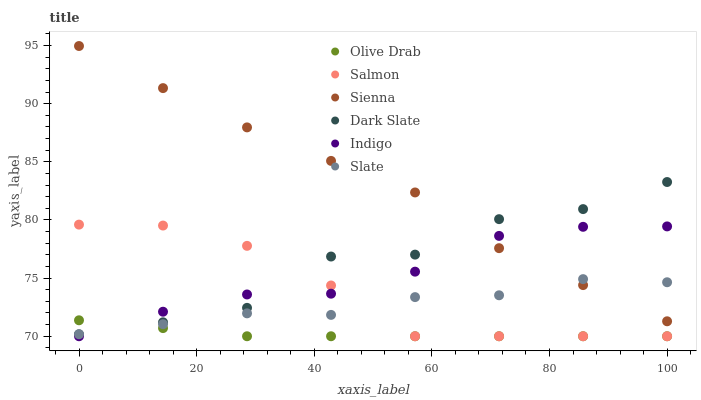Does Olive Drab have the minimum area under the curve?
Answer yes or no. Yes. Does Sienna have the maximum area under the curve?
Answer yes or no. Yes. Does Slate have the minimum area under the curve?
Answer yes or no. No. Does Slate have the maximum area under the curve?
Answer yes or no. No. Is Olive Drab the smoothest?
Answer yes or no. Yes. Is Dark Slate the roughest?
Answer yes or no. Yes. Is Slate the smoothest?
Answer yes or no. No. Is Slate the roughest?
Answer yes or no. No. Does Indigo have the lowest value?
Answer yes or no. Yes. Does Slate have the lowest value?
Answer yes or no. No. Does Sienna have the highest value?
Answer yes or no. Yes. Does Slate have the highest value?
Answer yes or no. No. Is Salmon less than Sienna?
Answer yes or no. Yes. Is Sienna greater than Salmon?
Answer yes or no. Yes. Does Dark Slate intersect Indigo?
Answer yes or no. Yes. Is Dark Slate less than Indigo?
Answer yes or no. No. Is Dark Slate greater than Indigo?
Answer yes or no. No. Does Salmon intersect Sienna?
Answer yes or no. No. 